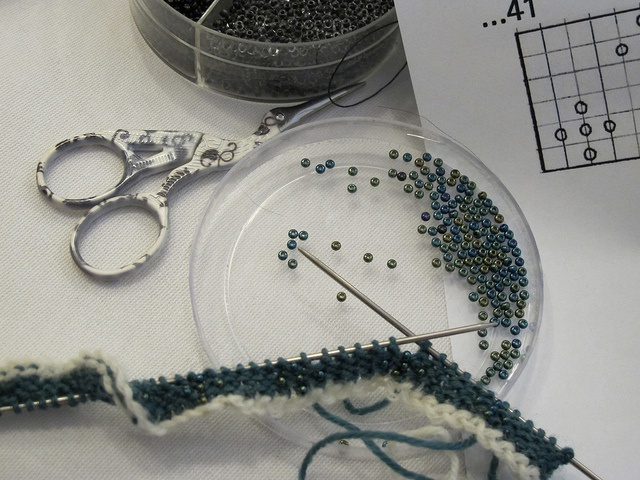Describe the objects in this image and their specific colors. I can see bowl in darkgray, black, and gray tones and scissors in darkgray, gray, and lightgray tones in this image. 